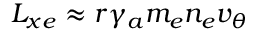<formula> <loc_0><loc_0><loc_500><loc_500>L _ { x e } \approx r \gamma _ { a } m _ { e } n _ { e } v _ { \theta }</formula> 